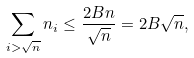Convert formula to latex. <formula><loc_0><loc_0><loc_500><loc_500>\sum _ { i > \sqrt { n } } n _ { i } \leq \frac { 2 B n } { \sqrt { n } } = 2 B \sqrt { n } ,</formula> 